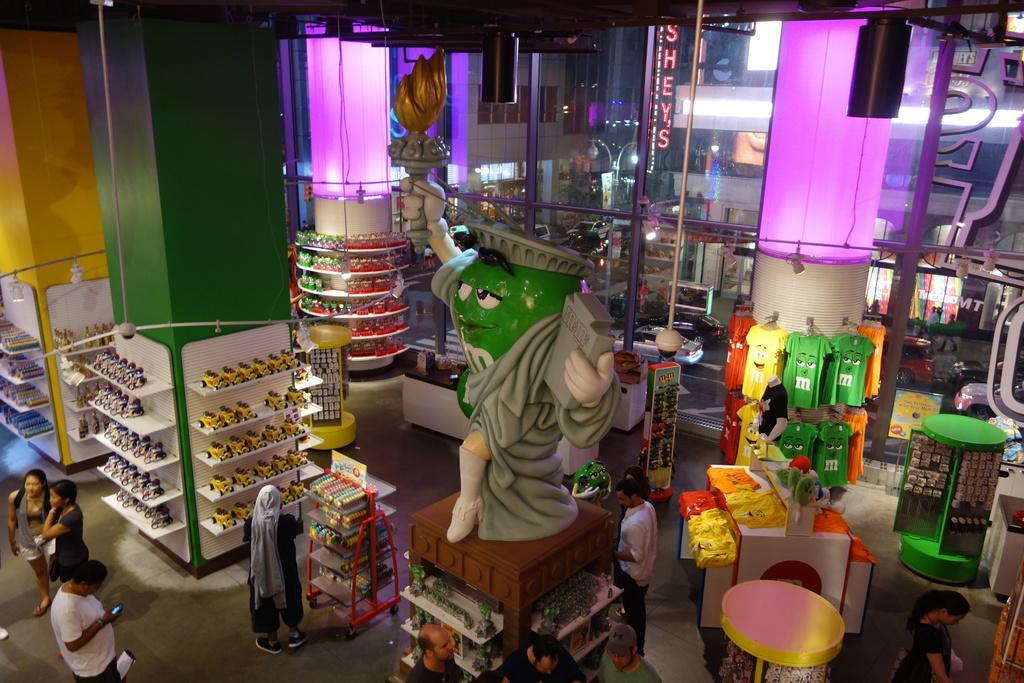In one or two sentences, can you explain what this image depicts? In this picture I can see there are few people standing and there are some toys and t-shirts here. 